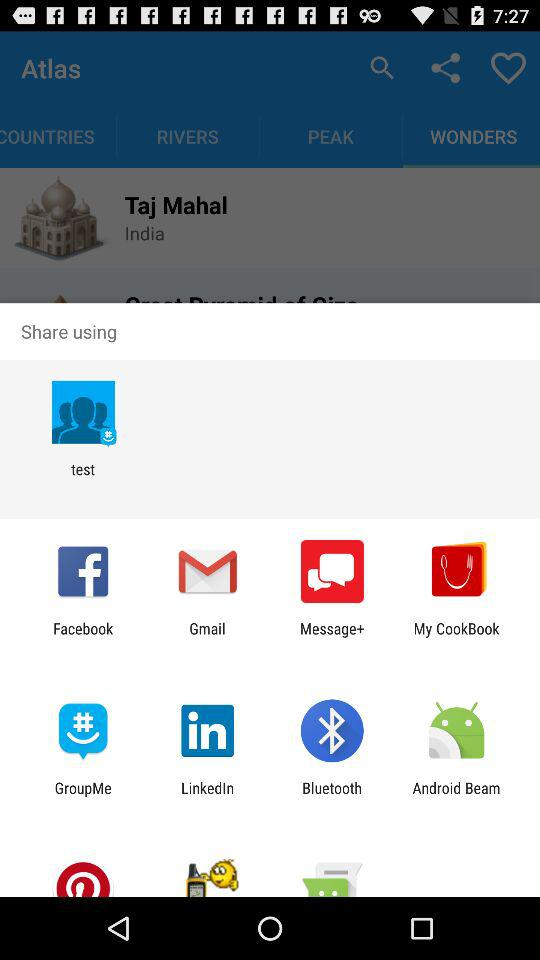What accounts can I use to share the content? You can share the content with "test", "Facebook", "Gmail", "Message+", "My CookBook", "GroupMe", "LinkedIn", "Bluetooth" and "Android Beam". 